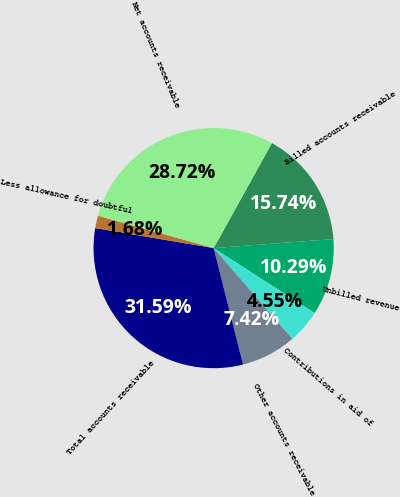<chart> <loc_0><loc_0><loc_500><loc_500><pie_chart><fcel>Billed accounts receivable<fcel>Unbilled revenue<fcel>Contributions in aid of<fcel>Other accounts receivable<fcel>Total accounts receivable<fcel>Less allowance for doubtful<fcel>Net accounts receivable<nl><fcel>15.74%<fcel>10.29%<fcel>4.55%<fcel>7.42%<fcel>31.59%<fcel>1.68%<fcel>28.72%<nl></chart> 